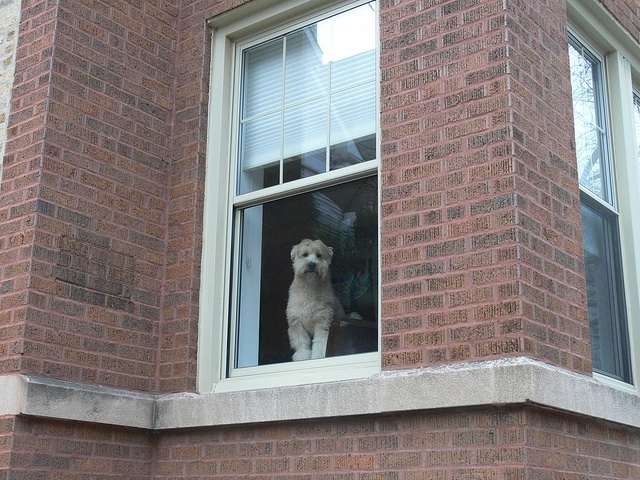Describe the objects in this image and their specific colors. I can see a dog in lightgray, gray, darkgray, and black tones in this image. 